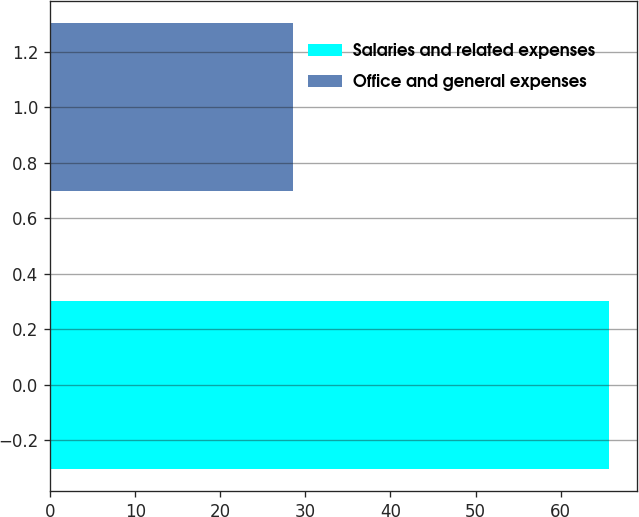Convert chart. <chart><loc_0><loc_0><loc_500><loc_500><bar_chart><fcel>Salaries and related expenses<fcel>Office and general expenses<nl><fcel>65.7<fcel>28.5<nl></chart> 